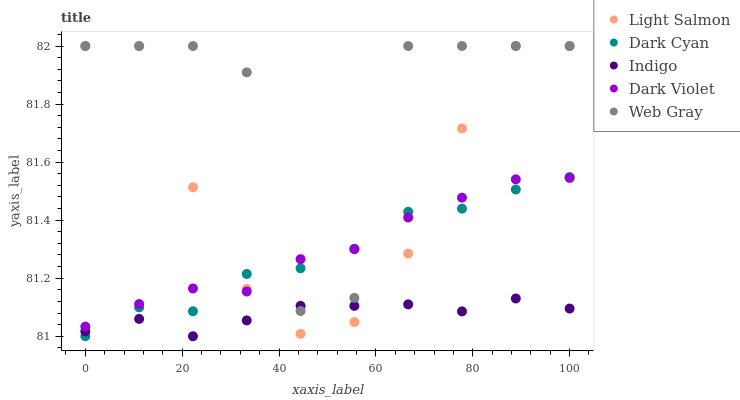Does Indigo have the minimum area under the curve?
Answer yes or no. Yes. Does Web Gray have the maximum area under the curve?
Answer yes or no. Yes. Does Light Salmon have the minimum area under the curve?
Answer yes or no. No. Does Light Salmon have the maximum area under the curve?
Answer yes or no. No. Is Indigo the smoothest?
Answer yes or no. Yes. Is Web Gray the roughest?
Answer yes or no. Yes. Is Light Salmon the smoothest?
Answer yes or no. No. Is Light Salmon the roughest?
Answer yes or no. No. Does Dark Cyan have the lowest value?
Answer yes or no. Yes. Does Light Salmon have the lowest value?
Answer yes or no. No. Does Web Gray have the highest value?
Answer yes or no. Yes. Does Indigo have the highest value?
Answer yes or no. No. Is Indigo less than Dark Violet?
Answer yes or no. Yes. Is Dark Violet greater than Indigo?
Answer yes or no. Yes. Does Light Salmon intersect Indigo?
Answer yes or no. Yes. Is Light Salmon less than Indigo?
Answer yes or no. No. Is Light Salmon greater than Indigo?
Answer yes or no. No. Does Indigo intersect Dark Violet?
Answer yes or no. No. 